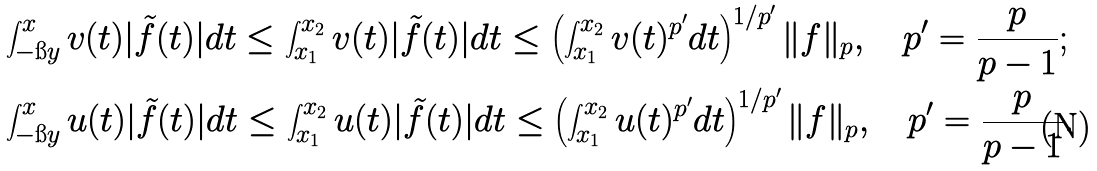<formula> <loc_0><loc_0><loc_500><loc_500>& \int _ { - \i y } ^ { x } v ( t ) | \tilde { f } ( t ) | d t \leq \int _ { x _ { 1 } } ^ { x _ { 2 } } v ( t ) | \tilde { f } ( t ) | d t \leq \left ( \int _ { x _ { 1 } } ^ { x _ { 2 } } v ( t ) ^ { p ^ { \prime } } d t \right ) ^ { 1 / p ^ { \prime } } \| f \| _ { p } , \quad p ^ { \prime } = \frac { p } { p - 1 } ; \\ & \int _ { - \i y } ^ { x } u ( t ) | \tilde { f } ( t ) | d t \leq \int _ { x _ { 1 } } ^ { x _ { 2 } } u ( t ) | \tilde { f } ( t ) | d t \leq \left ( \int _ { x _ { 1 } } ^ { x _ { 2 } } u ( t ) ^ { p ^ { \prime } } d t \right ) ^ { 1 / p ^ { \prime } } \| f \| _ { p } , \quad p ^ { \prime } = \frac { p } { p - 1 } .</formula> 